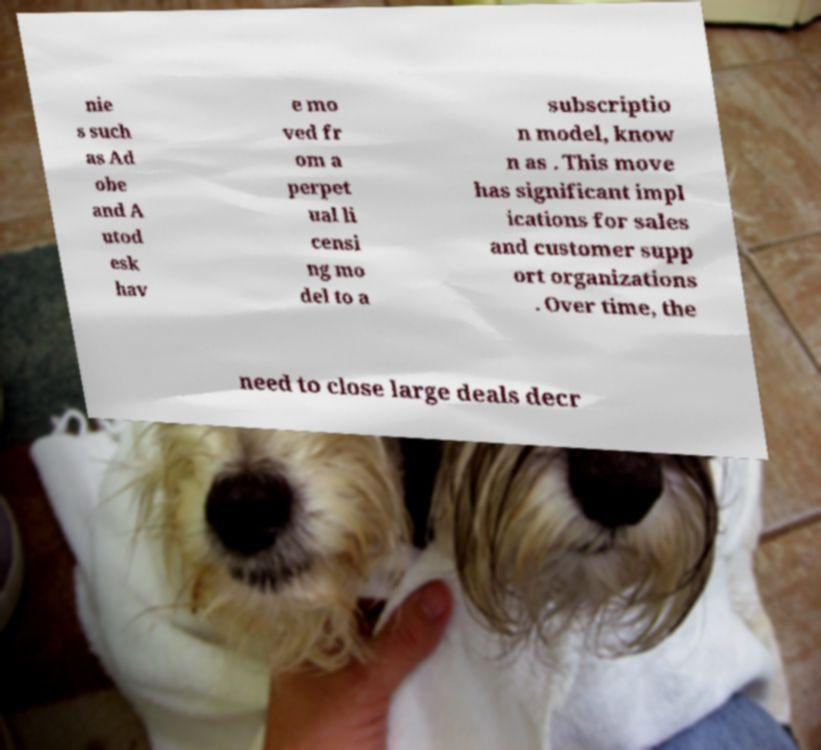Please read and relay the text visible in this image. What does it say? nie s such as Ad obe and A utod esk hav e mo ved fr om a perpet ual li censi ng mo del to a subscriptio n model, know n as . This move has significant impl ications for sales and customer supp ort organizations . Over time, the need to close large deals decr 